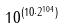Convert formula to latex. <formula><loc_0><loc_0><loc_500><loc_500>1 0 ^ { ( 1 0 \cdot 2 ^ { 1 0 4 } ) }</formula> 